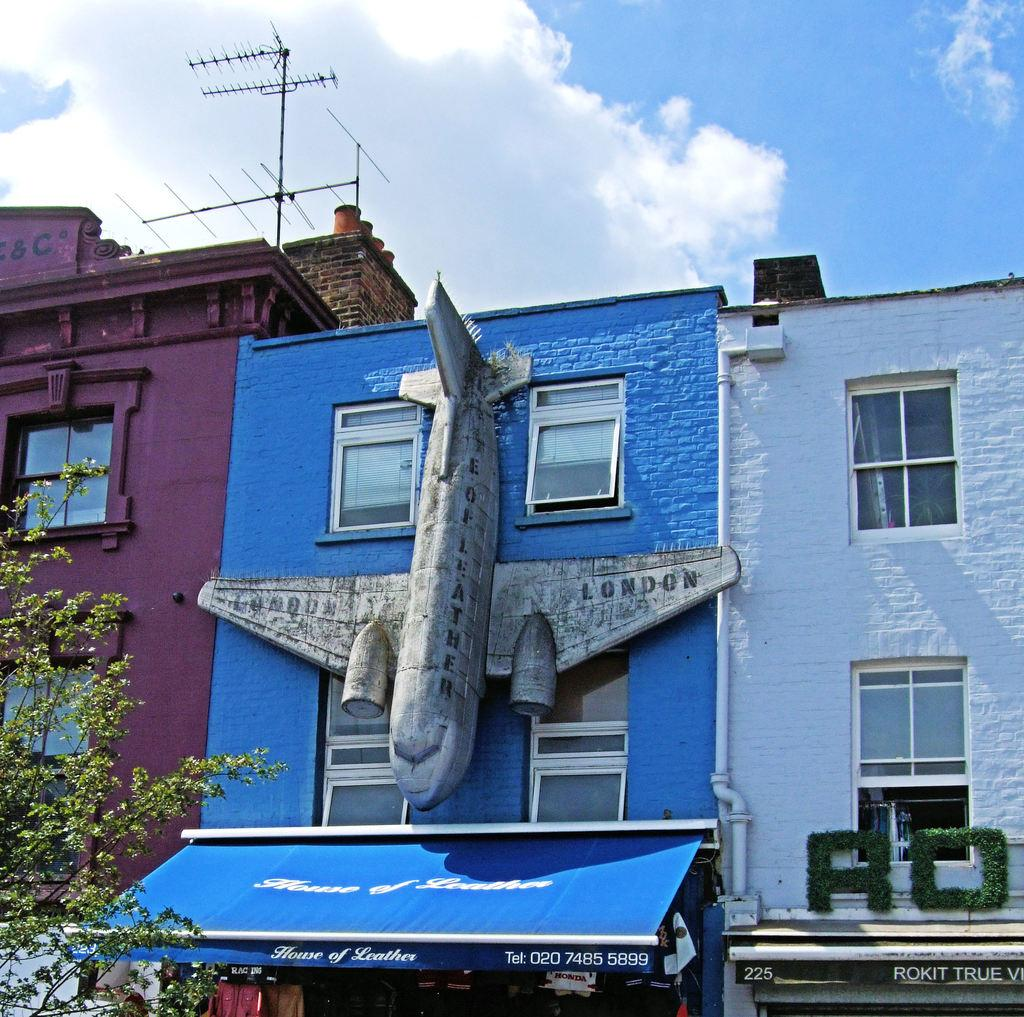How many buildings can be seen in the image? There are three buildings in the image. What is the shape on the blue color building? There is an airplane shape object on the blue color building. What is located on the left side of the image? There is a tree on the left side of the image. What can be seen in the sky in the image? There are clouds in the sky. What type of discussion is taking place near the tree in the image? There is no discussion taking place in the image, as it only features buildings, an airplane shape object, a tree, and clouds. Can you see any sea in the image? There is no sea visible in the image; it only features buildings, an airplane shape object, a tree, and clouds. 